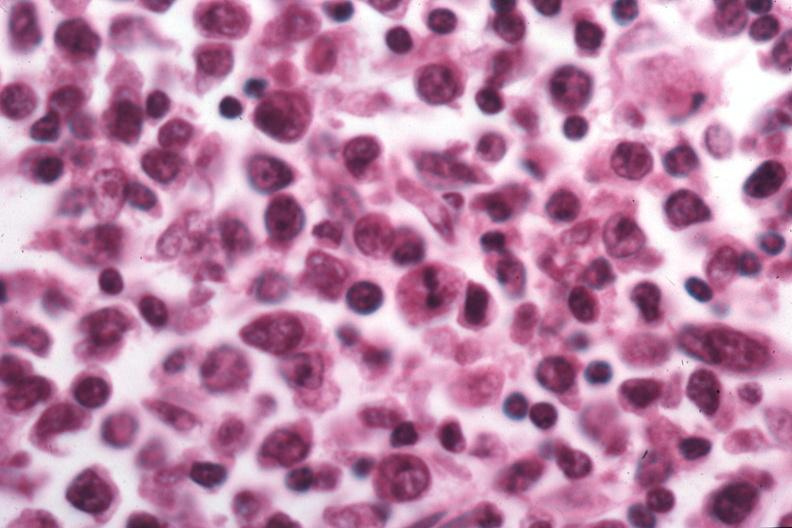what is present?
Answer the question using a single word or phrase. Lymph node 